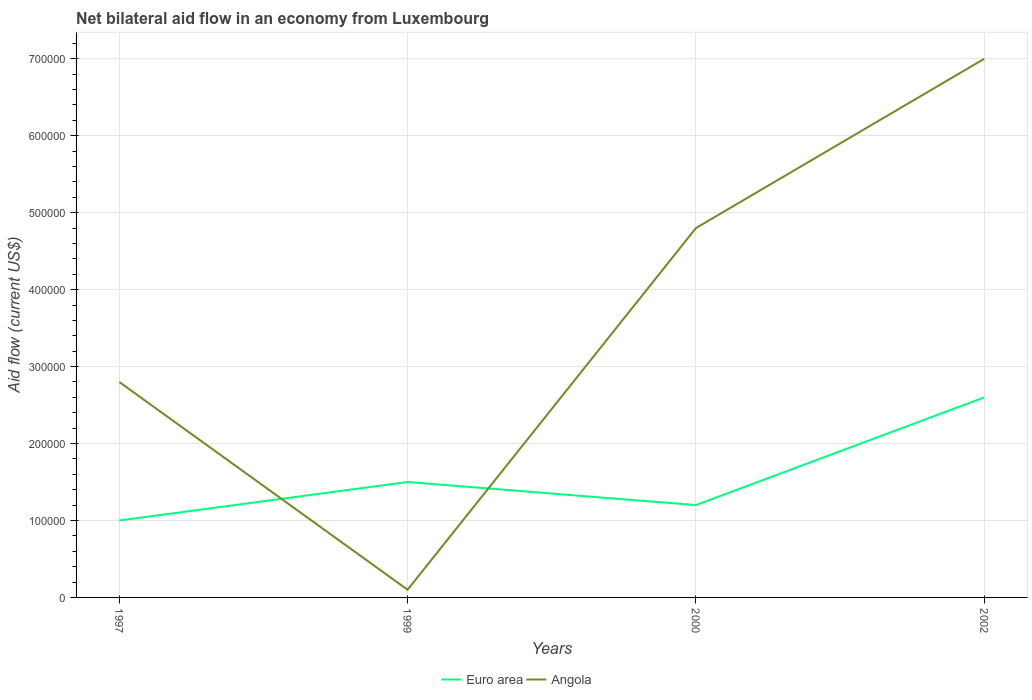How many different coloured lines are there?
Make the answer very short. 2. In which year was the net bilateral aid flow in Euro area maximum?
Your answer should be very brief. 1997. What is the total net bilateral aid flow in Angola in the graph?
Provide a succinct answer. -4.70e+05. What is the difference between the highest and the second highest net bilateral aid flow in Angola?
Offer a very short reply. 6.90e+05. How many years are there in the graph?
Offer a terse response. 4. Are the values on the major ticks of Y-axis written in scientific E-notation?
Provide a short and direct response. No. Does the graph contain any zero values?
Offer a very short reply. No. How are the legend labels stacked?
Ensure brevity in your answer.  Horizontal. What is the title of the graph?
Your answer should be compact. Net bilateral aid flow in an economy from Luxembourg. What is the label or title of the Y-axis?
Your answer should be compact. Aid flow (current US$). What is the Aid flow (current US$) of Angola in 1997?
Your answer should be compact. 2.80e+05. What is the Aid flow (current US$) in Angola in 1999?
Keep it short and to the point. 10000. What is the Aid flow (current US$) of Euro area in 2002?
Your response must be concise. 2.60e+05. Across all years, what is the maximum Aid flow (current US$) of Angola?
Offer a terse response. 7.00e+05. Across all years, what is the minimum Aid flow (current US$) in Angola?
Ensure brevity in your answer.  10000. What is the total Aid flow (current US$) of Euro area in the graph?
Offer a very short reply. 6.30e+05. What is the total Aid flow (current US$) of Angola in the graph?
Provide a short and direct response. 1.47e+06. What is the difference between the Aid flow (current US$) of Euro area in 1997 and that in 1999?
Your answer should be very brief. -5.00e+04. What is the difference between the Aid flow (current US$) in Angola in 1997 and that in 1999?
Your response must be concise. 2.70e+05. What is the difference between the Aid flow (current US$) in Euro area in 1997 and that in 2000?
Your answer should be very brief. -2.00e+04. What is the difference between the Aid flow (current US$) of Angola in 1997 and that in 2002?
Make the answer very short. -4.20e+05. What is the difference between the Aid flow (current US$) in Angola in 1999 and that in 2000?
Offer a very short reply. -4.70e+05. What is the difference between the Aid flow (current US$) in Euro area in 1999 and that in 2002?
Offer a terse response. -1.10e+05. What is the difference between the Aid flow (current US$) of Angola in 1999 and that in 2002?
Your answer should be very brief. -6.90e+05. What is the difference between the Aid flow (current US$) of Angola in 2000 and that in 2002?
Your answer should be compact. -2.20e+05. What is the difference between the Aid flow (current US$) of Euro area in 1997 and the Aid flow (current US$) of Angola in 2000?
Provide a short and direct response. -3.80e+05. What is the difference between the Aid flow (current US$) in Euro area in 1997 and the Aid flow (current US$) in Angola in 2002?
Offer a terse response. -6.00e+05. What is the difference between the Aid flow (current US$) in Euro area in 1999 and the Aid flow (current US$) in Angola in 2000?
Offer a terse response. -3.30e+05. What is the difference between the Aid flow (current US$) of Euro area in 1999 and the Aid flow (current US$) of Angola in 2002?
Offer a terse response. -5.50e+05. What is the difference between the Aid flow (current US$) in Euro area in 2000 and the Aid flow (current US$) in Angola in 2002?
Give a very brief answer. -5.80e+05. What is the average Aid flow (current US$) of Euro area per year?
Provide a short and direct response. 1.58e+05. What is the average Aid flow (current US$) of Angola per year?
Give a very brief answer. 3.68e+05. In the year 2000, what is the difference between the Aid flow (current US$) of Euro area and Aid flow (current US$) of Angola?
Keep it short and to the point. -3.60e+05. In the year 2002, what is the difference between the Aid flow (current US$) of Euro area and Aid flow (current US$) of Angola?
Provide a short and direct response. -4.40e+05. What is the ratio of the Aid flow (current US$) in Euro area in 1997 to that in 1999?
Make the answer very short. 0.67. What is the ratio of the Aid flow (current US$) in Angola in 1997 to that in 1999?
Ensure brevity in your answer.  28. What is the ratio of the Aid flow (current US$) of Angola in 1997 to that in 2000?
Your answer should be very brief. 0.58. What is the ratio of the Aid flow (current US$) of Euro area in 1997 to that in 2002?
Provide a short and direct response. 0.38. What is the ratio of the Aid flow (current US$) of Angola in 1997 to that in 2002?
Your response must be concise. 0.4. What is the ratio of the Aid flow (current US$) of Angola in 1999 to that in 2000?
Provide a short and direct response. 0.02. What is the ratio of the Aid flow (current US$) of Euro area in 1999 to that in 2002?
Provide a short and direct response. 0.58. What is the ratio of the Aid flow (current US$) in Angola in 1999 to that in 2002?
Make the answer very short. 0.01. What is the ratio of the Aid flow (current US$) of Euro area in 2000 to that in 2002?
Provide a short and direct response. 0.46. What is the ratio of the Aid flow (current US$) of Angola in 2000 to that in 2002?
Offer a terse response. 0.69. What is the difference between the highest and the second highest Aid flow (current US$) of Euro area?
Keep it short and to the point. 1.10e+05. What is the difference between the highest and the second highest Aid flow (current US$) in Angola?
Provide a succinct answer. 2.20e+05. What is the difference between the highest and the lowest Aid flow (current US$) of Euro area?
Provide a short and direct response. 1.60e+05. What is the difference between the highest and the lowest Aid flow (current US$) of Angola?
Keep it short and to the point. 6.90e+05. 